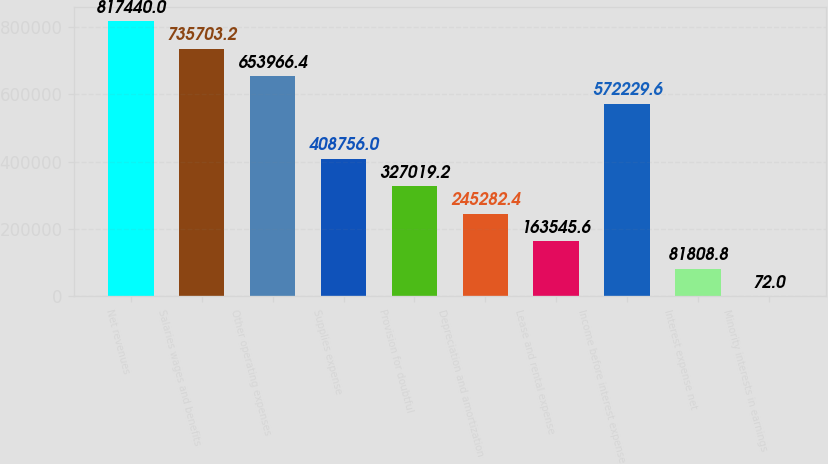<chart> <loc_0><loc_0><loc_500><loc_500><bar_chart><fcel>Net revenues<fcel>Salaries wages and benefits<fcel>Other operating expenses<fcel>Supplies expense<fcel>Provision for doubtful<fcel>Depreciation and amortization<fcel>Lease and rental expense<fcel>Income before interest expense<fcel>Interest expense net<fcel>Minority interests in earnings<nl><fcel>817440<fcel>735703<fcel>653966<fcel>408756<fcel>327019<fcel>245282<fcel>163546<fcel>572230<fcel>81808.8<fcel>72<nl></chart> 